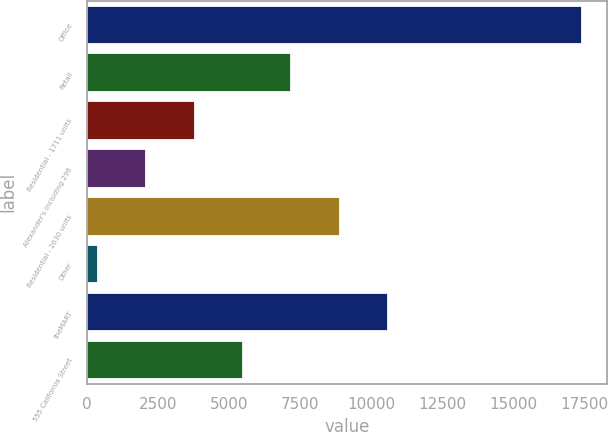<chart> <loc_0><loc_0><loc_500><loc_500><bar_chart><fcel>Office<fcel>Retail<fcel>Residential - 1711 units<fcel>Alexander's including 296<fcel>Residential - 2630 units<fcel>Other<fcel>theMART<fcel>555 California Street<nl><fcel>17412<fcel>7196.4<fcel>3791.2<fcel>2088.6<fcel>8899<fcel>386<fcel>10601.6<fcel>5493.8<nl></chart> 